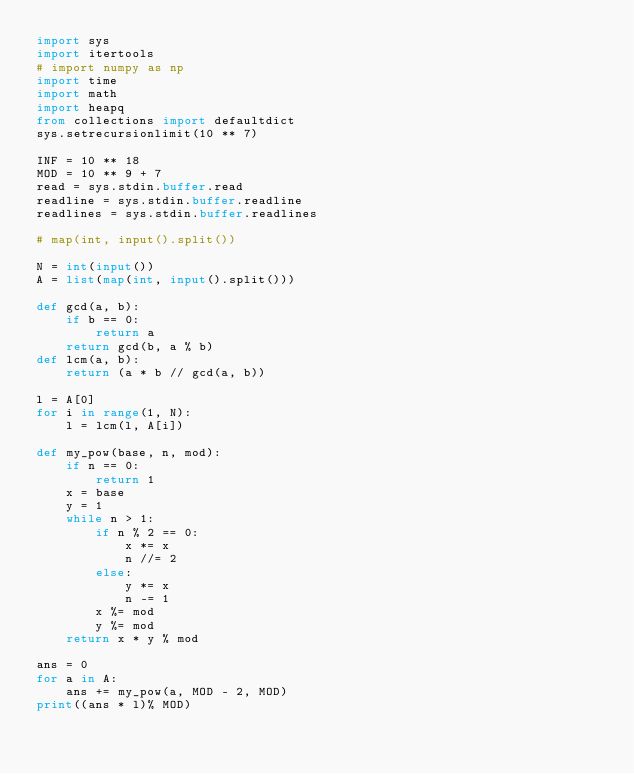Convert code to text. <code><loc_0><loc_0><loc_500><loc_500><_Python_>import sys
import itertools
# import numpy as np
import time
import math
import heapq
from collections import defaultdict
sys.setrecursionlimit(10 ** 7)
 
INF = 10 ** 18
MOD = 10 ** 9 + 7
read = sys.stdin.buffer.read
readline = sys.stdin.buffer.readline
readlines = sys.stdin.buffer.readlines

# map(int, input().split())

N = int(input())
A = list(map(int, input().split()))

def gcd(a, b):
    if b == 0:
        return a
    return gcd(b, a % b)
def lcm(a, b):
    return (a * b // gcd(a, b))

l = A[0]
for i in range(1, N):
    l = lcm(l, A[i])

def my_pow(base, n, mod):
    if n == 0:
        return 1
    x = base
    y = 1
    while n > 1:
        if n % 2 == 0:
            x *= x
            n //= 2
        else:
            y *= x
            n -= 1
        x %= mod
        y %= mod
    return x * y % mod

ans = 0
for a in A:
    ans += my_pow(a, MOD - 2, MOD)
print((ans * l)% MOD)</code> 